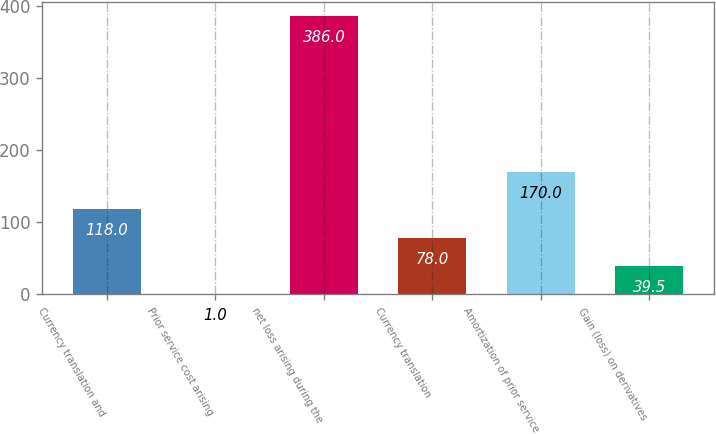Convert chart. <chart><loc_0><loc_0><loc_500><loc_500><bar_chart><fcel>Currency translation and<fcel>Prior service cost arising<fcel>net loss arising during the<fcel>Currency translation<fcel>Amortization of prior service<fcel>Gain (loss) on derivatives<nl><fcel>118<fcel>1<fcel>386<fcel>78<fcel>170<fcel>39.5<nl></chart> 